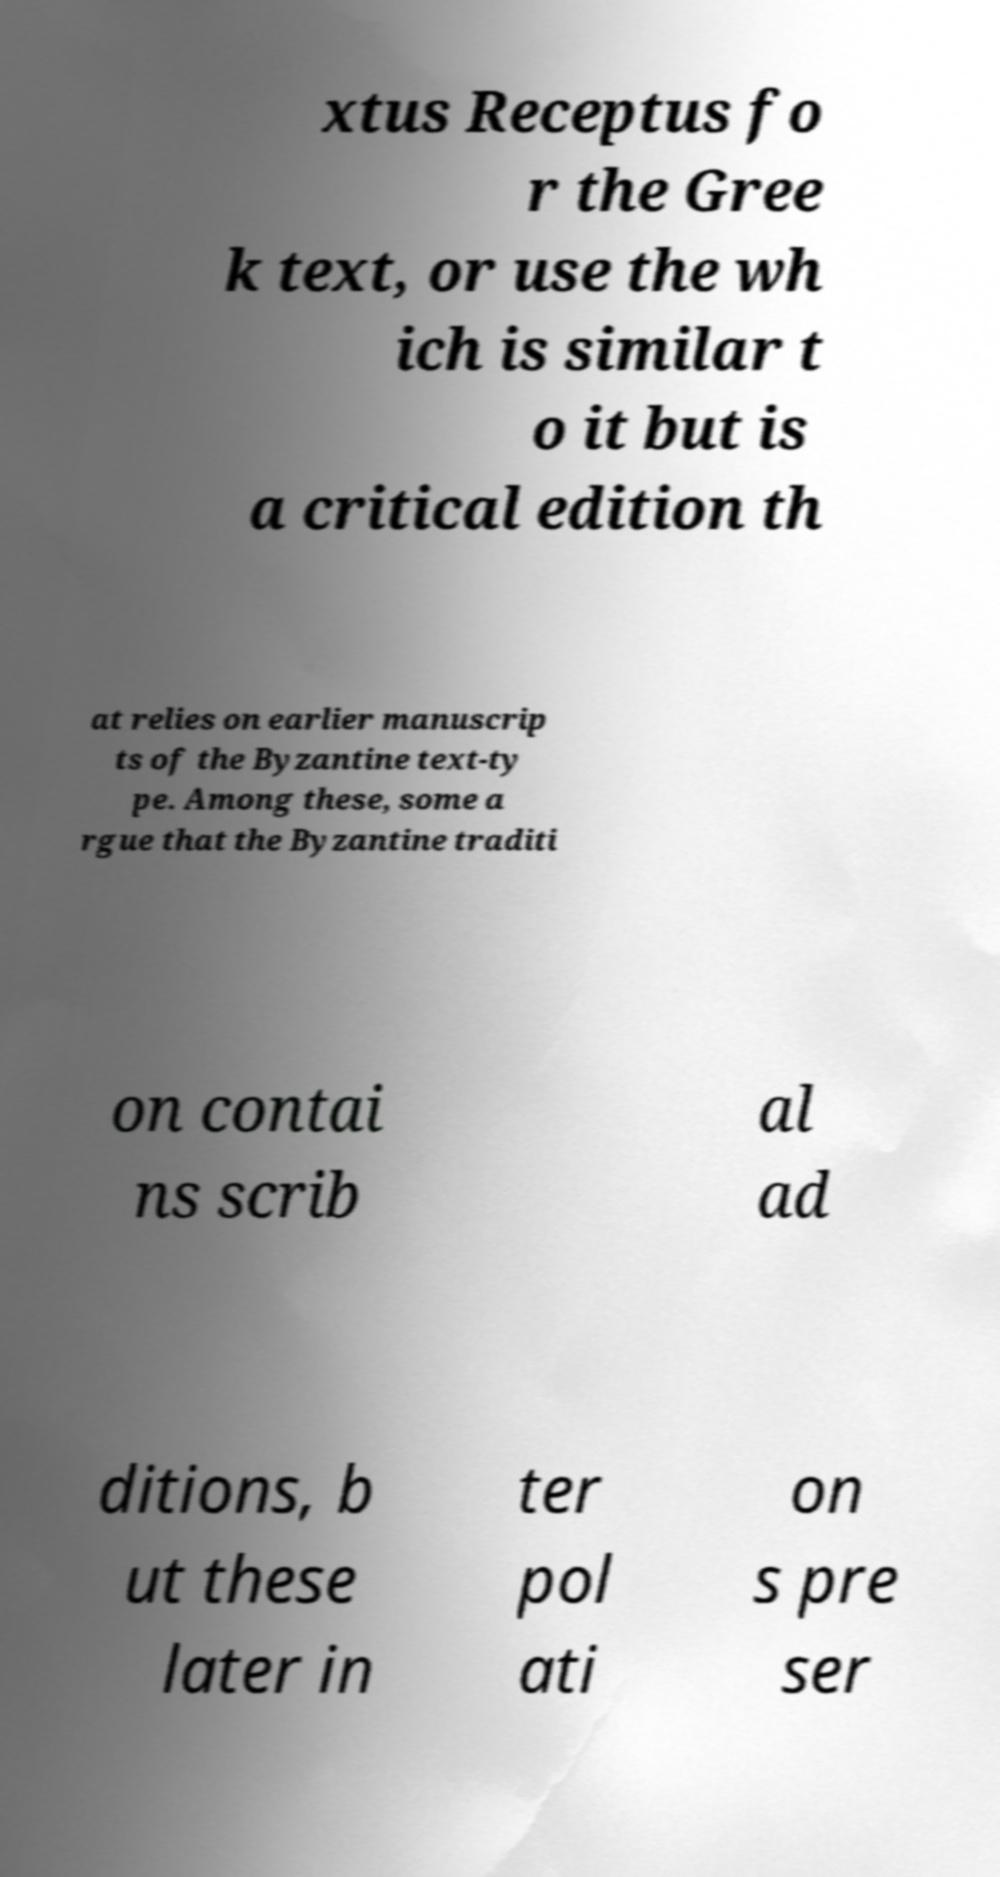What messages or text are displayed in this image? I need them in a readable, typed format. xtus Receptus fo r the Gree k text, or use the wh ich is similar t o it but is a critical edition th at relies on earlier manuscrip ts of the Byzantine text-ty pe. Among these, some a rgue that the Byzantine traditi on contai ns scrib al ad ditions, b ut these later in ter pol ati on s pre ser 